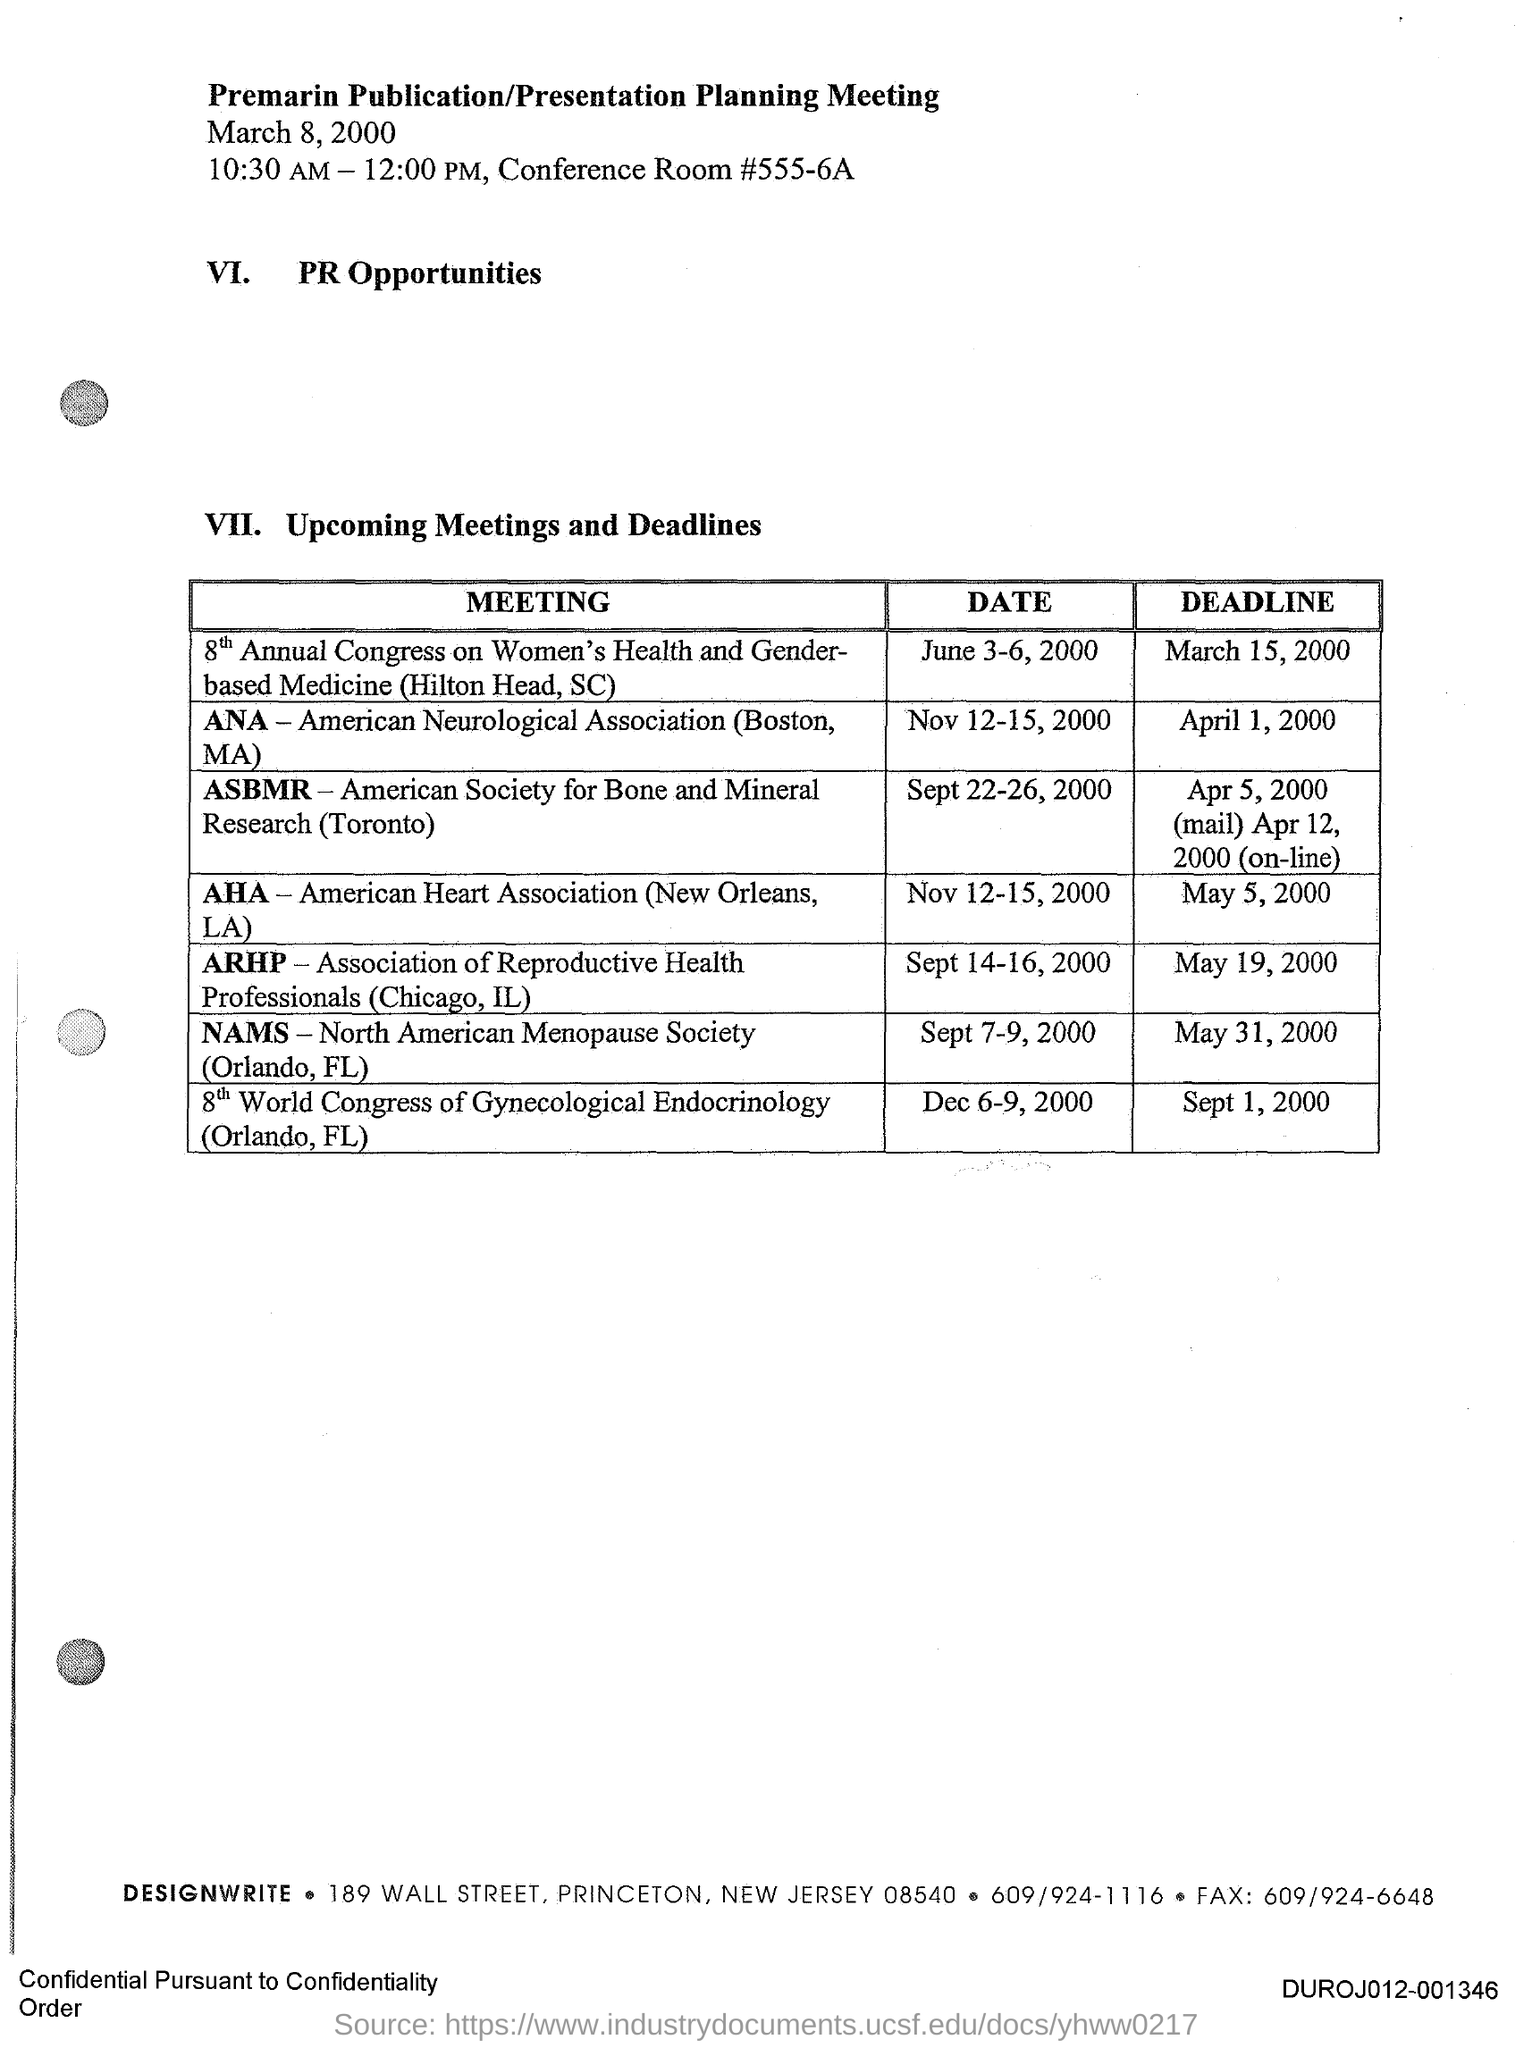Draw attention to some important aspects in this diagram. The full form of AHA is American Heart Association. The deadline for "AHA" is May 5, 2000. The title of the document is "Premarin Publication/Presentation Planning Meeting." The deadline for ANA is April 1, 2000. DESIGNWRITE's fax number is 609/924-6648. 